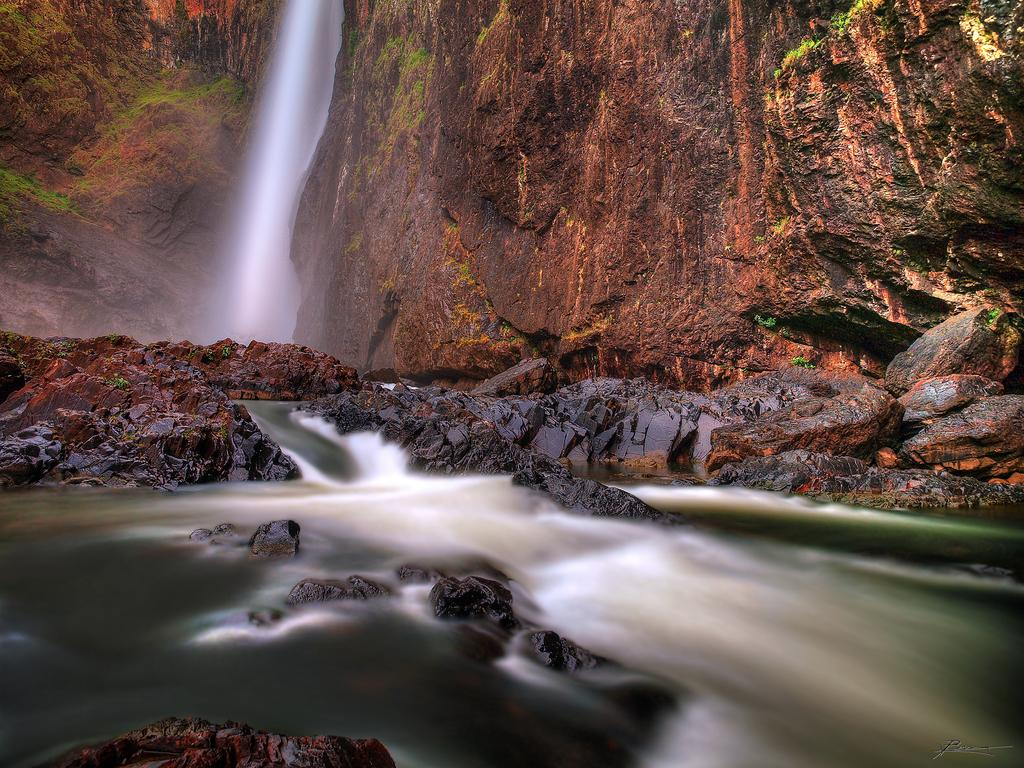What is at the bottom of the image? There is water at the bottom of the image. What can be found in the middle of the image? There are stones in the middle of the image. What is located at the top of the image? There is a hill and a waterfall at the top of the image. Can you see an ant carrying a hot cup of approval in the image? There is no ant, hot cup, or approval present in the image. 